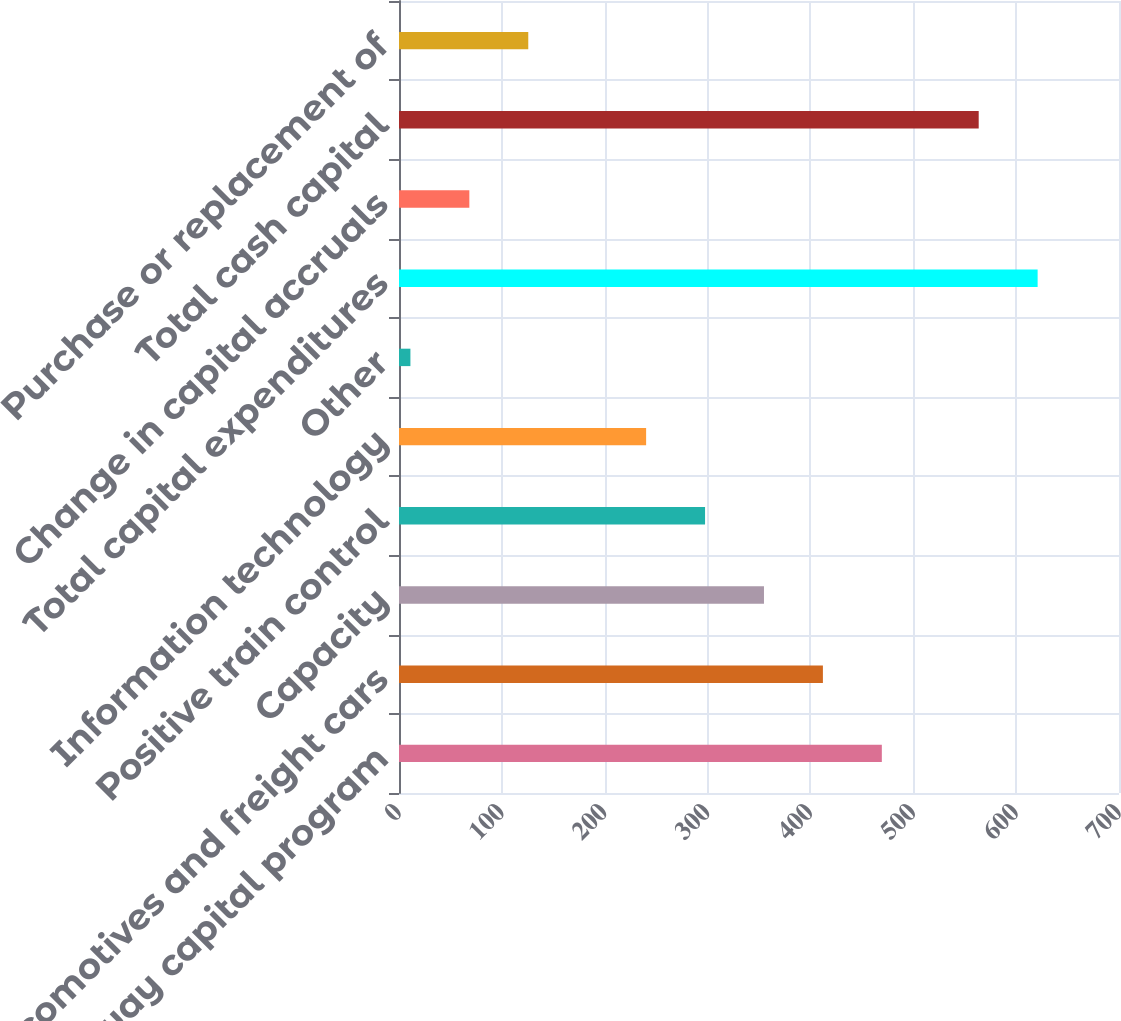<chart> <loc_0><loc_0><loc_500><loc_500><bar_chart><fcel>Roadway capital program<fcel>Locomotives and freight cars<fcel>Capacity<fcel>Positive train control<fcel>Information technology<fcel>Other<fcel>Total capital expenditures<fcel>Change in capital accruals<fcel>Total cash capital<fcel>Purchase or replacement of<nl><fcel>469.42<fcel>412.13<fcel>354.84<fcel>297.55<fcel>240.26<fcel>11.1<fcel>620.89<fcel>68.39<fcel>563.6<fcel>125.68<nl></chart> 